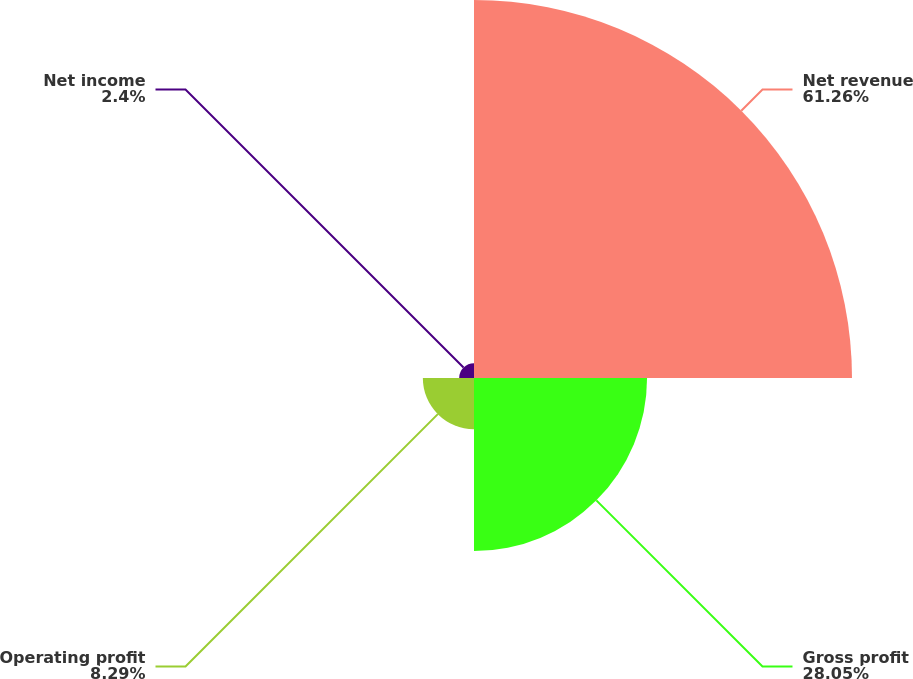<chart> <loc_0><loc_0><loc_500><loc_500><pie_chart><fcel>Net revenue<fcel>Gross profit<fcel>Operating profit<fcel>Net income<nl><fcel>61.27%<fcel>28.05%<fcel>8.29%<fcel>2.4%<nl></chart> 